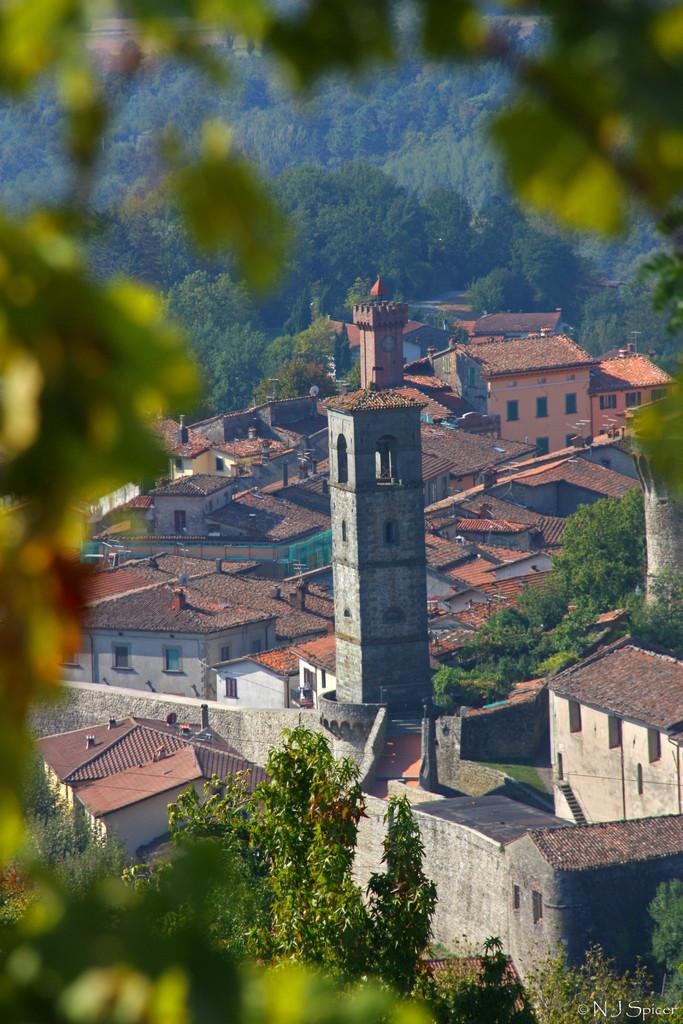What type of structures can be seen in the image? There are buildings in the image. What type of vegetation is present in the image? There are trees in the image. What type of pets can be seen in the image? There are no pets visible in the image; it only features buildings and trees. Where is the train station located in the image? There is no train station present in the image. 